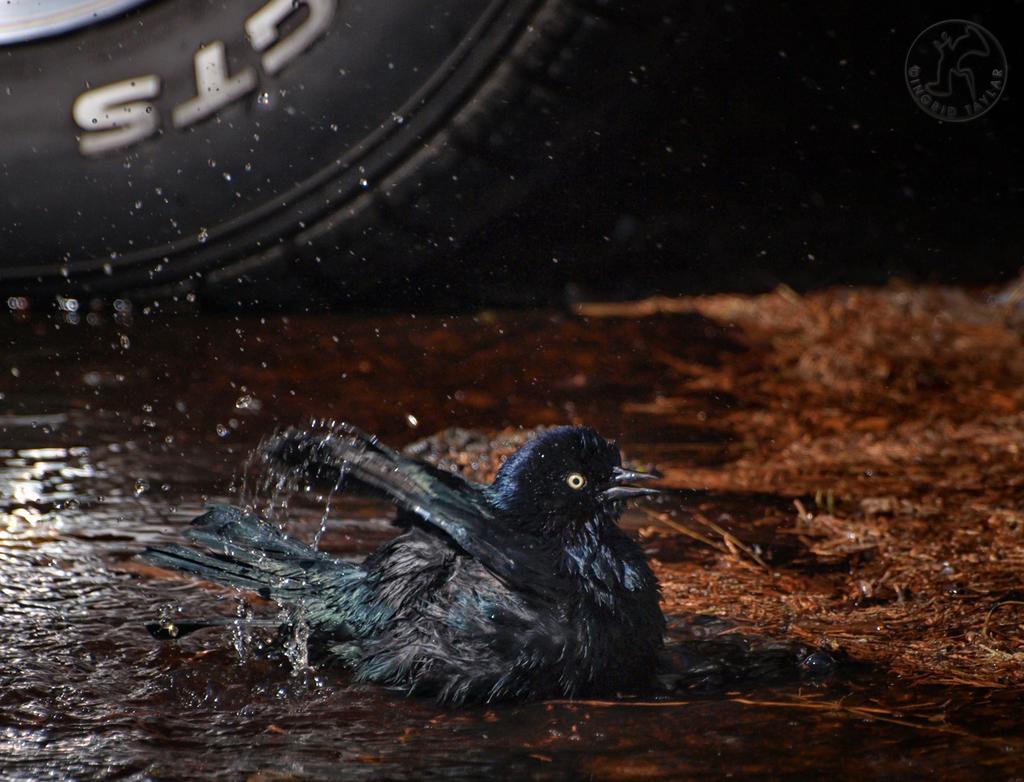How would you summarize this image in a sentence or two? In this image I can see a black color bird. I can see a water and black color tier. I can see a brown floor. 